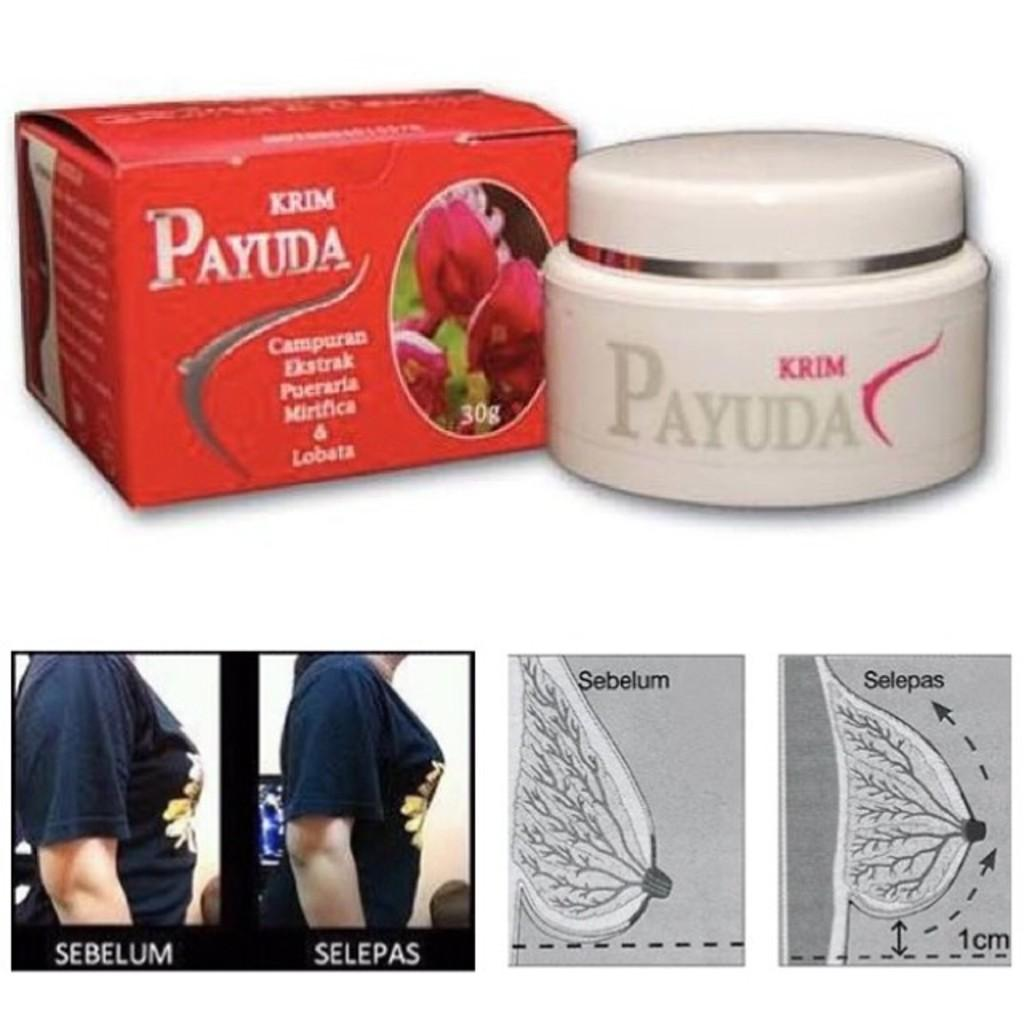<image>
Summarize the visual content of the image. A container of cream labeled Payuda over top of images of a woman wearing a blue t shirt. 